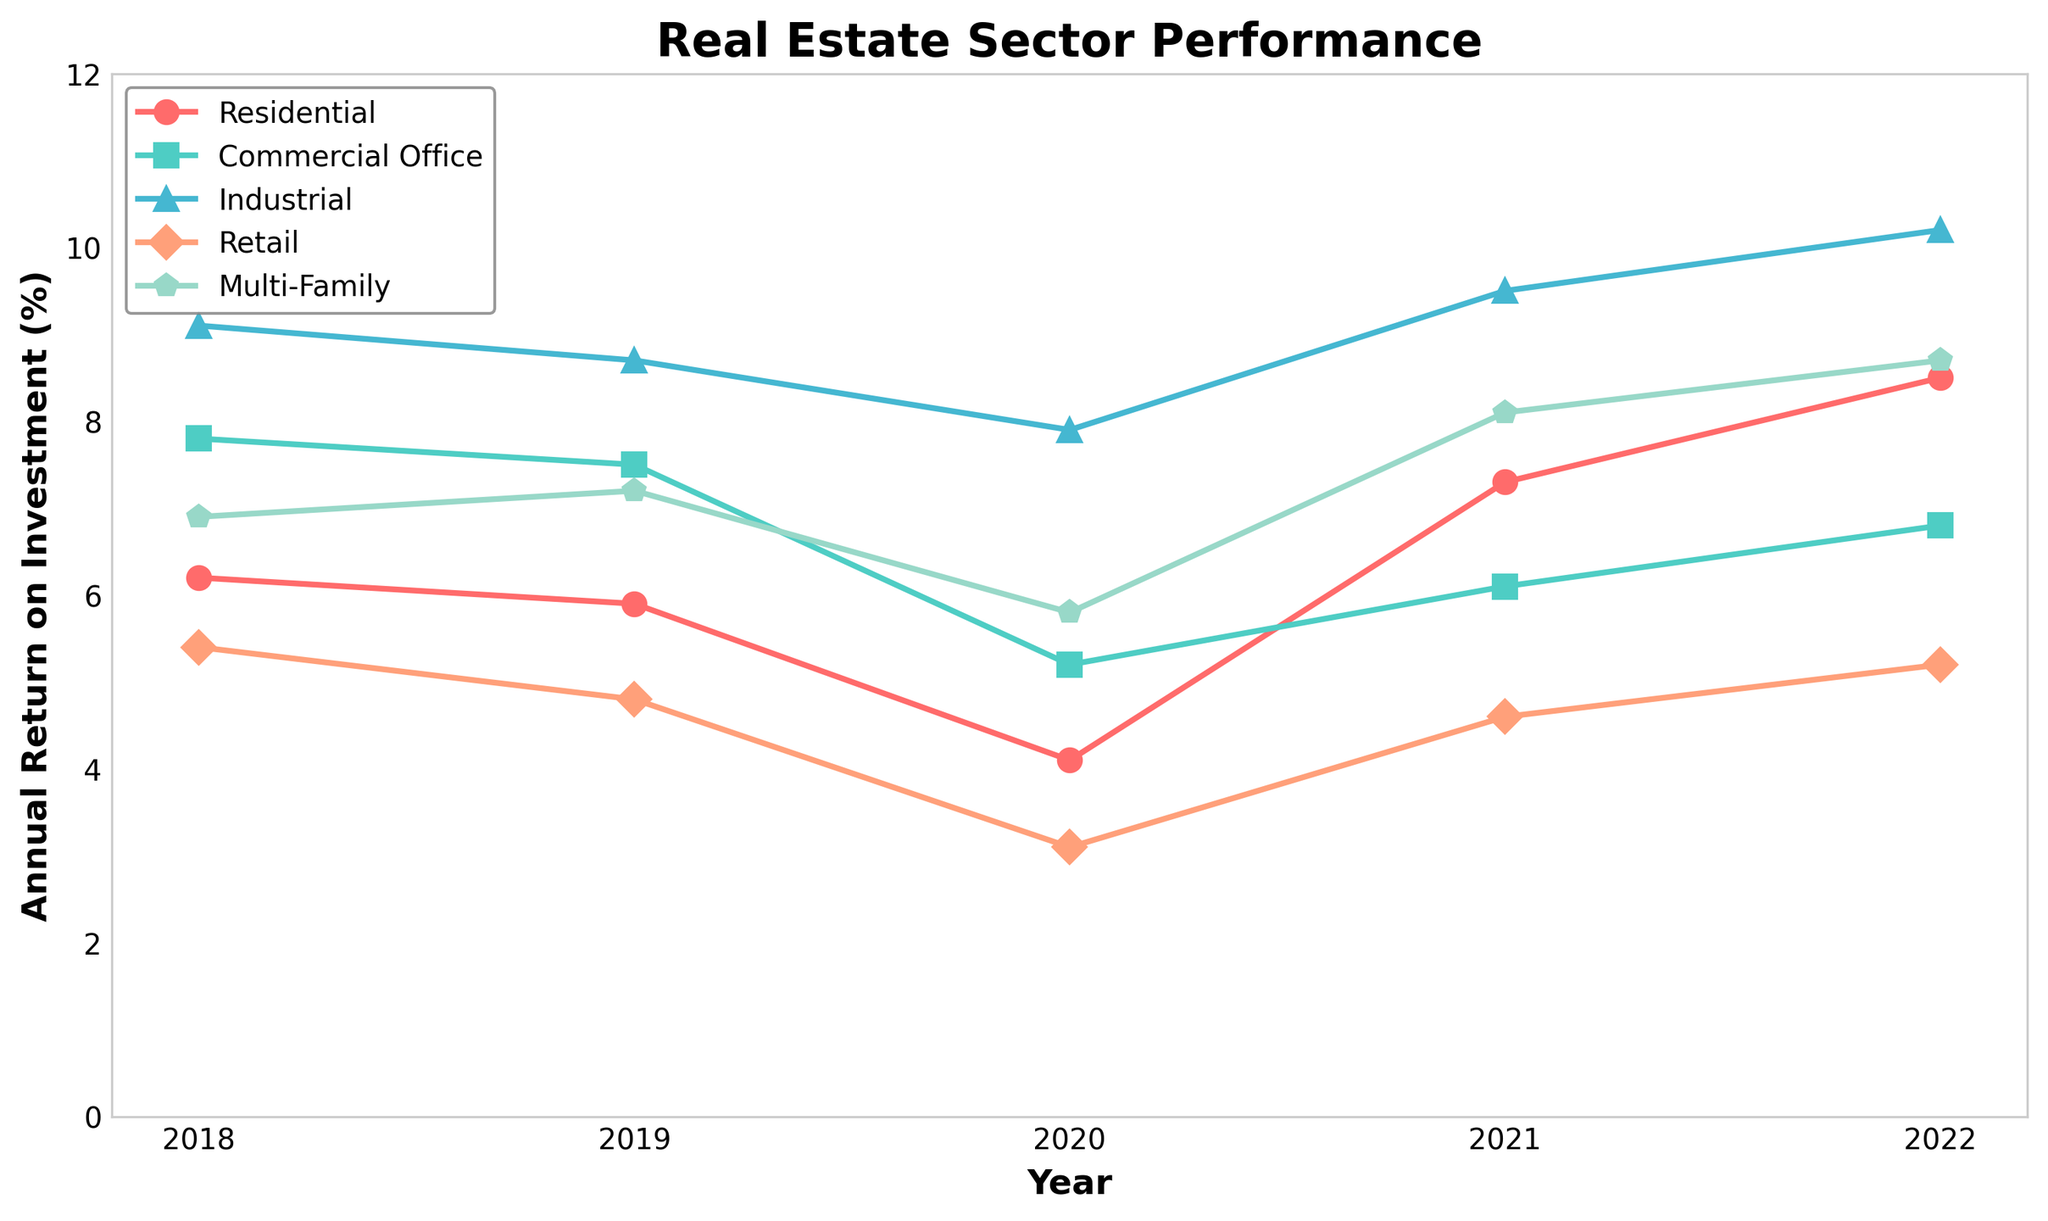what is the difference in ROI between Industrial and Retail sectors in 2022? In 2022, the Industrial sector had a ROI of 10.2%, while the Retail sector had 5.2%. The difference is 10.2% - 5.2% = 5%
Answer: 5% Which sector had the highest ROI in 2021? In the year 2021, the Industrial sector had the highest ROI at 9.5% compared to the other sectors.
Answer: Industrial What is the average ROI for the Multi-Family sector from 2018 to 2022? The ROIs for Multi-Family are 6.9, 7.2, 5.8, 8.1, and 8.7 for the years 2018 to 2022. Summing them up, 6.9 + 7.2 + 5.8 + 8.1 + 8.7 = 36.7. The average is 36.7 / 5 = 7.34%
Answer: 7.34% Which sector shows the most significant increase in ROI from 2020 to 2021? The increase in ROI from 2020 to 2021 is calculated for each sector. Residential: 7.3% - 4.1% = 3.2%, Commercial Office: 6.1% - 5.2% = 0.9%, Industrial: 9.5% - 7.9% = 1.6%, Retail: 4.6% - 3.1% = 1.5%, Multi-Family: 8.1% - 5.8% = 2.3%. Residential sector shows the most significant increase with 3.2%
Answer: Residential Identify the trend of the Commercial Office sector’s ROI from 2018 to 2022. The ROI for Commercial Office in 2018 was 7.8%, 2019 was 7.5%, 2020 was 5.2%, 2021 was 6.1%, and 2022 was 6.8%. The trend shows a decrease from 2018 to 2019, a further drop to 2020, and then an increase again through 2021 and 2022.
Answer: Decrease, Drop, Increase What is the combined average ROI for Residential and Retail sectors in 2022? The ROI for Residential in 2022 is 8.5%, and for Retail, it is 5.2%. To find the combined average, we sum these values and divide by 2. (8.5% + 5.2%) / 2 = 6.85%
Answer: 6.85% How many sectors had a higher ROI in 2020 compared to Residential? The ROI for Residential in 2020 was 4.1%. In the same year, the ROIs for the other sectors were Commercial Office 5.2%, Industrial 7.9%, Retail 3.1%, Multi-Family 5.8%. The sectors with higher ROI than Residential in 2020 are Commercial Office, Industrial, and Multi-Family (3 sectors).
Answer: 3 Which sector's ROI is represented by the blue line with triangular markers? By visual inspection and knowledge of the used color and marker mapping, the blue line with triangular markers represents the Industrial sector.
Answer: Industrial What is the total ROI for Commercial Office sector across all years? The ROI for Commercial Office over the years 2018 to 2022 is 7.8, 7.5, 5.2, 6.1, and 6.8. The total is calculated as 7.8 + 7.5 + 5.2 + 6.1 + 6.8 = 33.4%
Answer: 33.4% Which year showed the lowest ROI for the Retail sector? The data shows the ROI for Retail was 5.4% in 2018, 4.8% in 2019, 3.1% in 2020, 4.6% in 2021, and 5.2% in 2022. The lowest was in 2020 at 3.1%.
Answer: 2020 